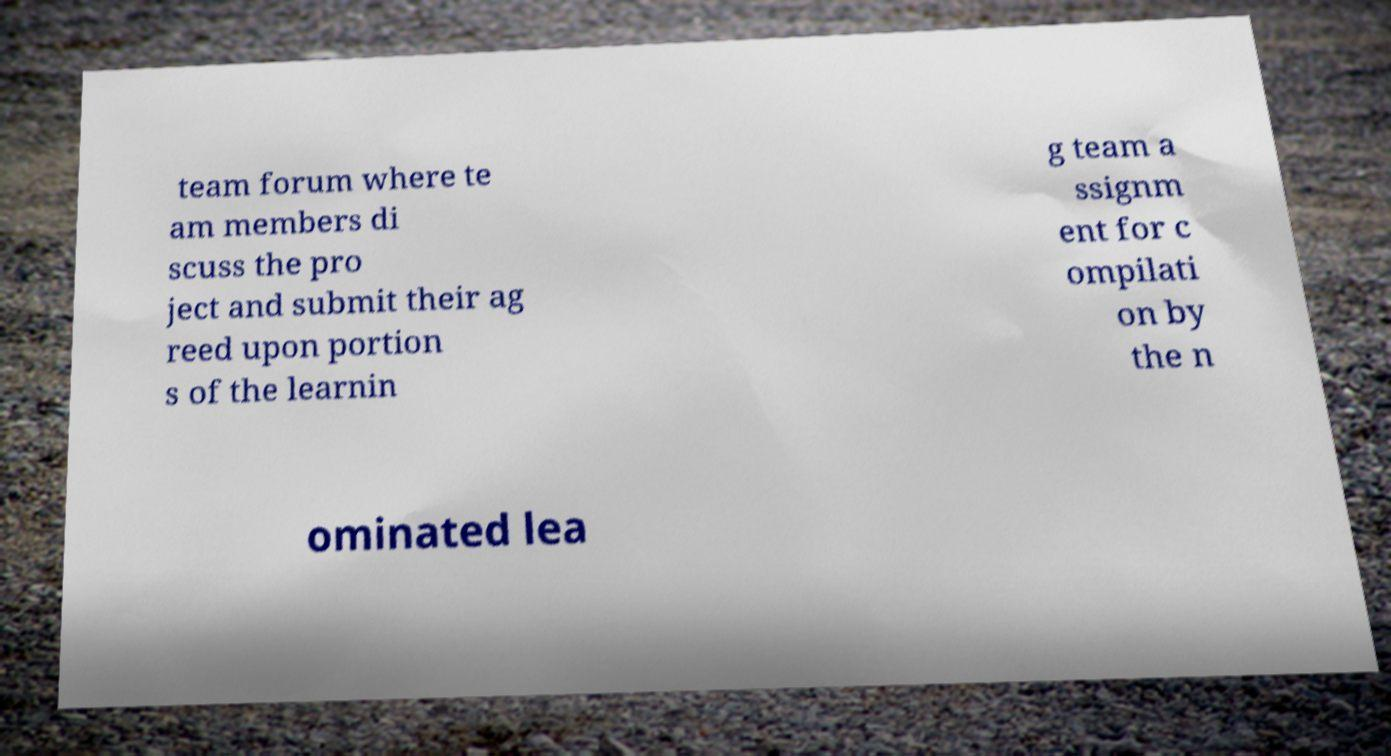Could you assist in decoding the text presented in this image and type it out clearly? team forum where te am members di scuss the pro ject and submit their ag reed upon portion s of the learnin g team a ssignm ent for c ompilati on by the n ominated lea 